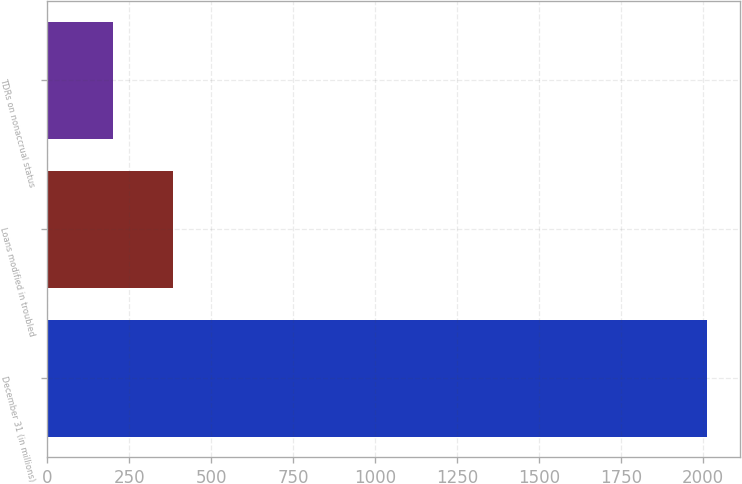<chart> <loc_0><loc_0><loc_500><loc_500><bar_chart><fcel>December 31 (in millions)<fcel>Loans modified in troubled<fcel>TDRs on nonaccrual status<nl><fcel>2013<fcel>382.2<fcel>201<nl></chart> 